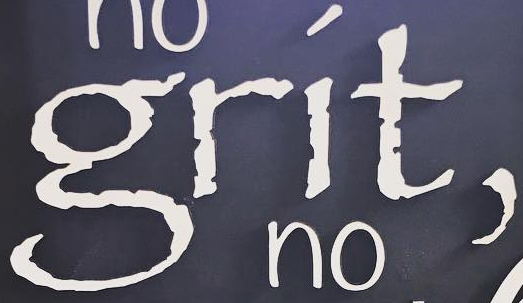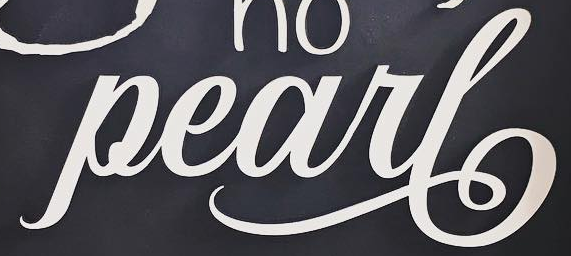Read the text from these images in sequence, separated by a semicolon. grít,; Pearl 